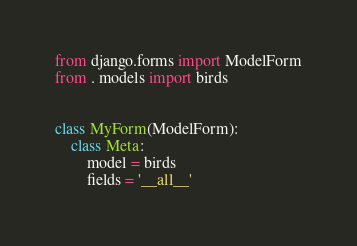<code> <loc_0><loc_0><loc_500><loc_500><_Python_>from django.forms import ModelForm
from . models import birds


class MyForm(ModelForm):
    class Meta:
        model = birds
        fields = '__all__'
</code> 